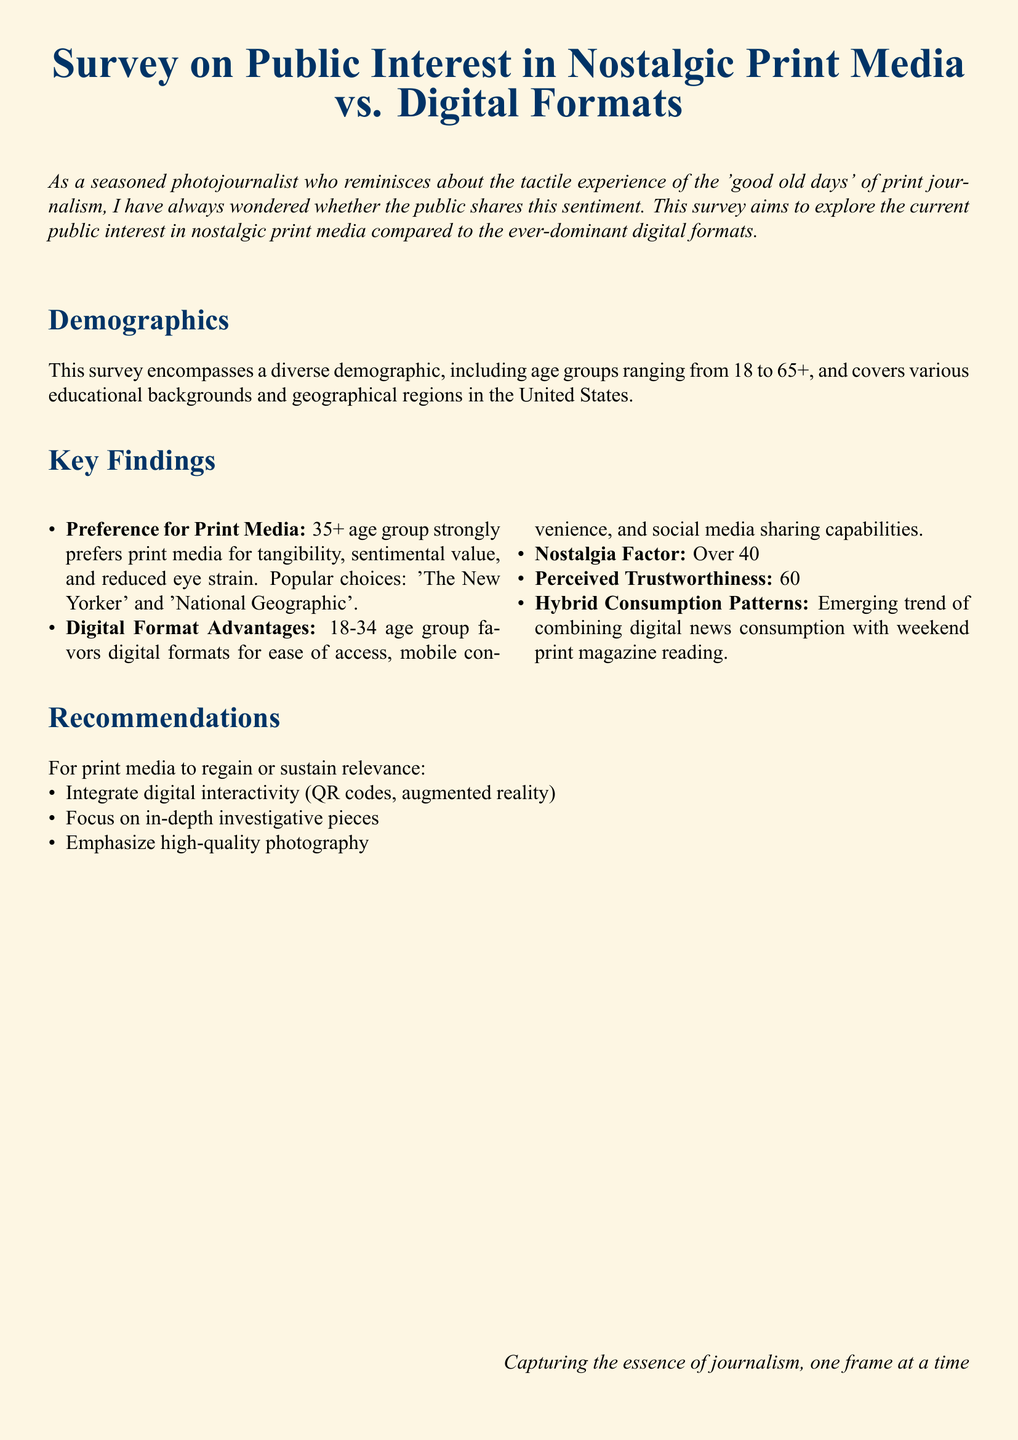What is the age group that strongly prefers print media? The document states that the 35+ age group strongly prefers print media.
Answer: 35+ What percentage of people feel nostalgic about print media? According to the document, over 40% feel nostalgic about print media.
Answer: Over 40% Which two print media are mentioned as popular choices? The document lists 'The New Yorker' and 'National Geographic' as popular print choices.
Answer: The New Yorker and National Geographic What is a reason why 60% find print media more credible? The document mentions higher editorial standards and fact-checking as a reason for perceived credibility in print media.
Answer: Higher editorial standards What is one recommendation for print media to remain relevant? The document suggests integrating digital interactivity as a recommendation for print media.
Answer: Integrate digital interactivity 